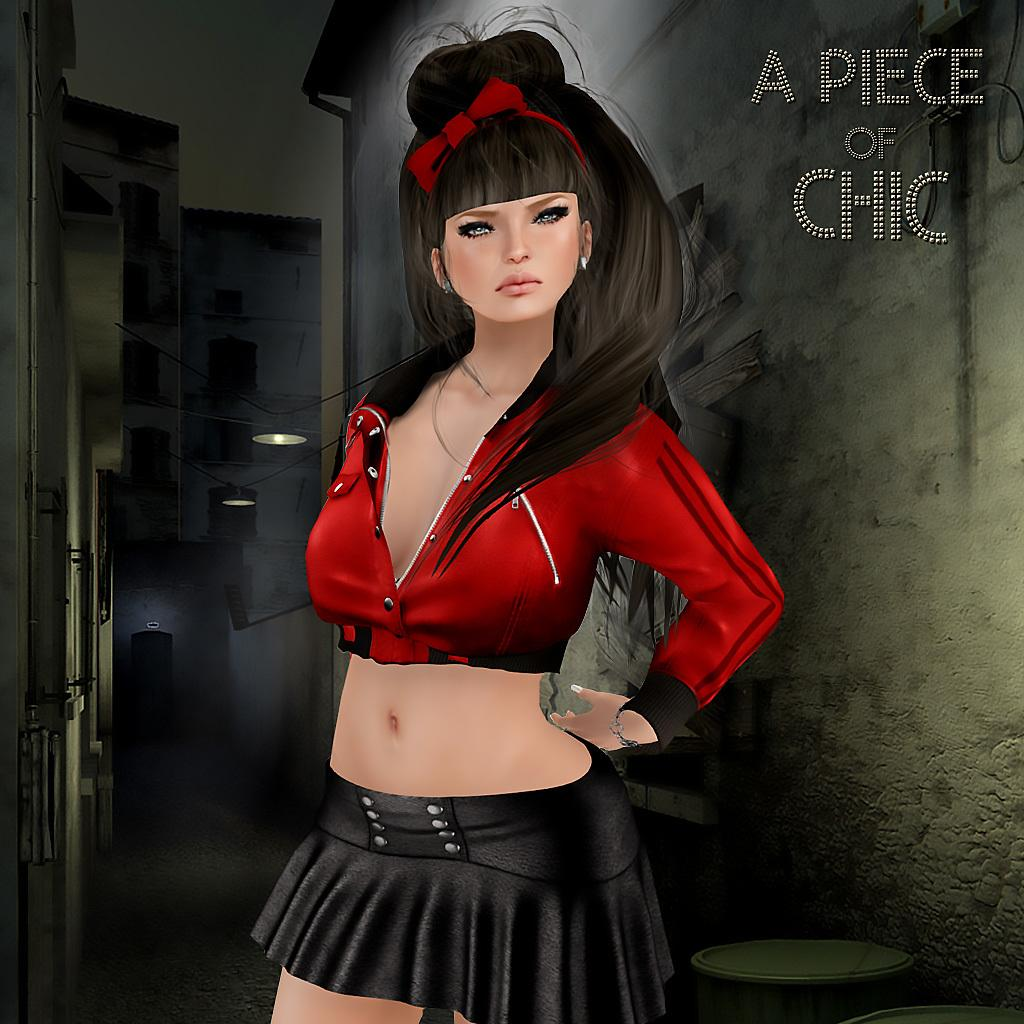What is the main subject of the image? There is a depiction of a woman in the image. What is the woman wearing in the image? The woman is wearing a red and black dress in the image. Is there any text or writing visible in the image? Yes, there is text or writing visible in the image. What type of protest is the woman leading in the image? There is no protest depicted in the image. The image only shows a depiction of a woman wearing a red and black dress, and there is text or writing visible in the image. 